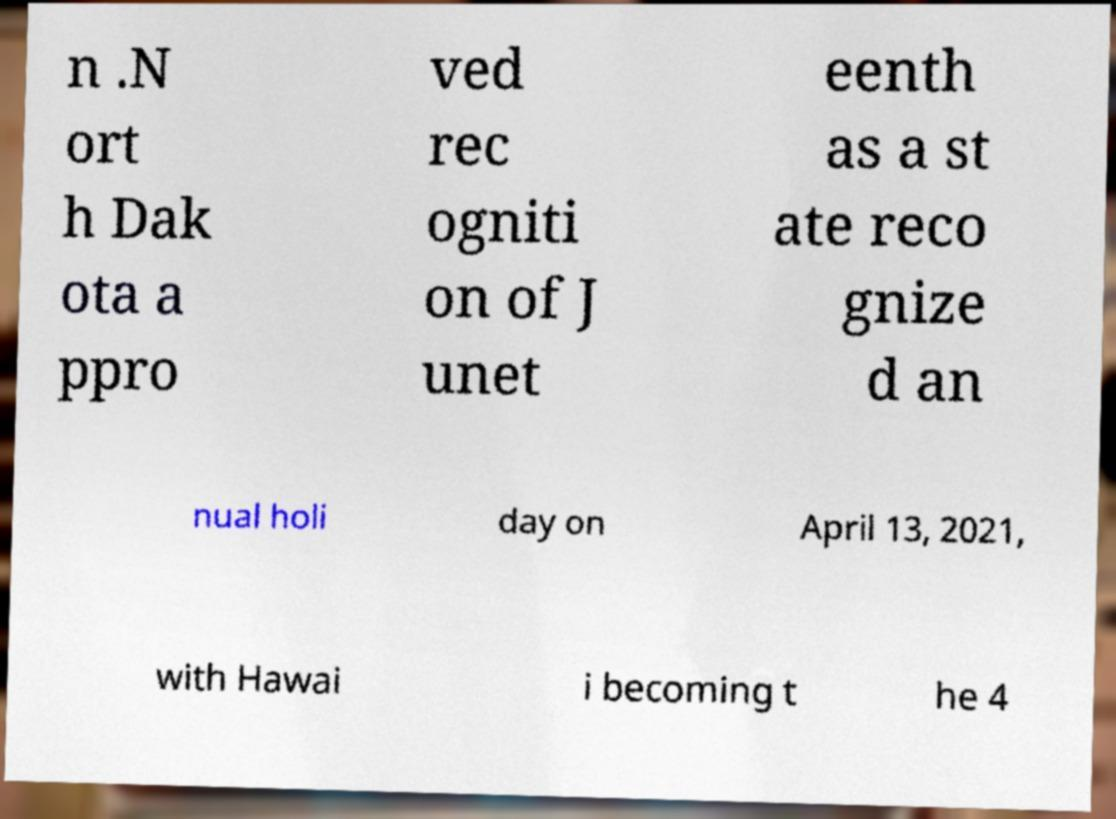What messages or text are displayed in this image? I need them in a readable, typed format. n .N ort h Dak ota a ppro ved rec ogniti on of J unet eenth as a st ate reco gnize d an nual holi day on April 13, 2021, with Hawai i becoming t he 4 